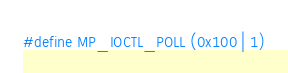Convert code to text. <code><loc_0><loc_0><loc_500><loc_500><_C_>#define MP_IOCTL_POLL (0x100 | 1)
</code> 